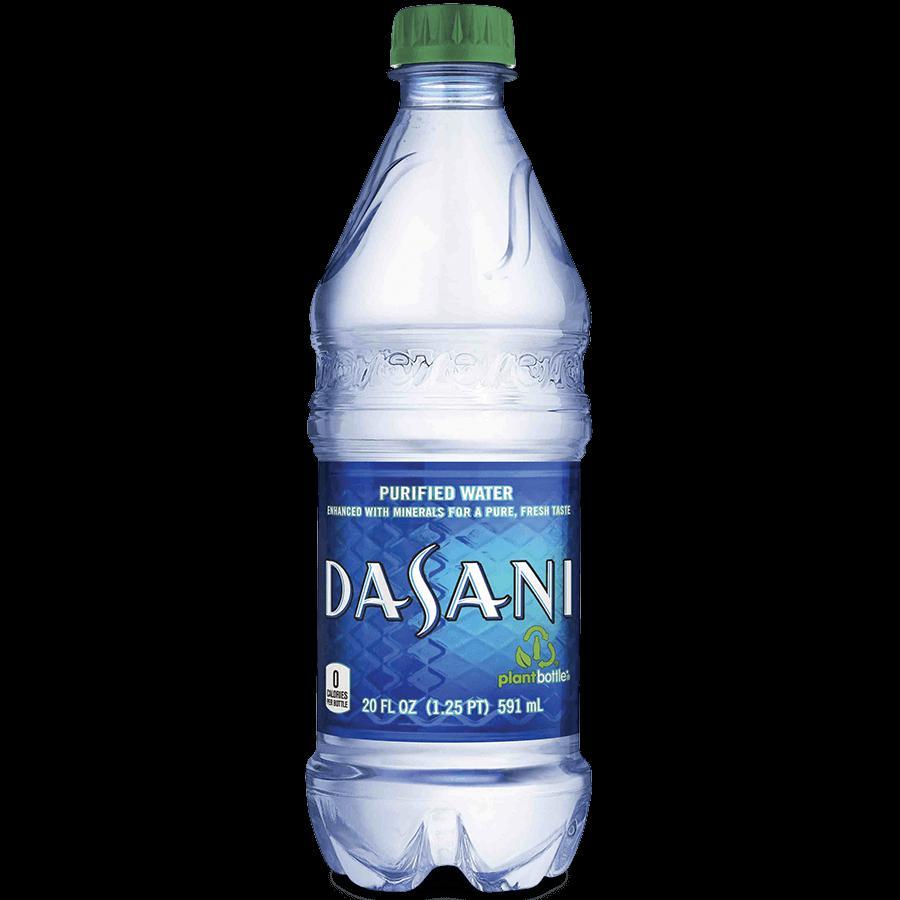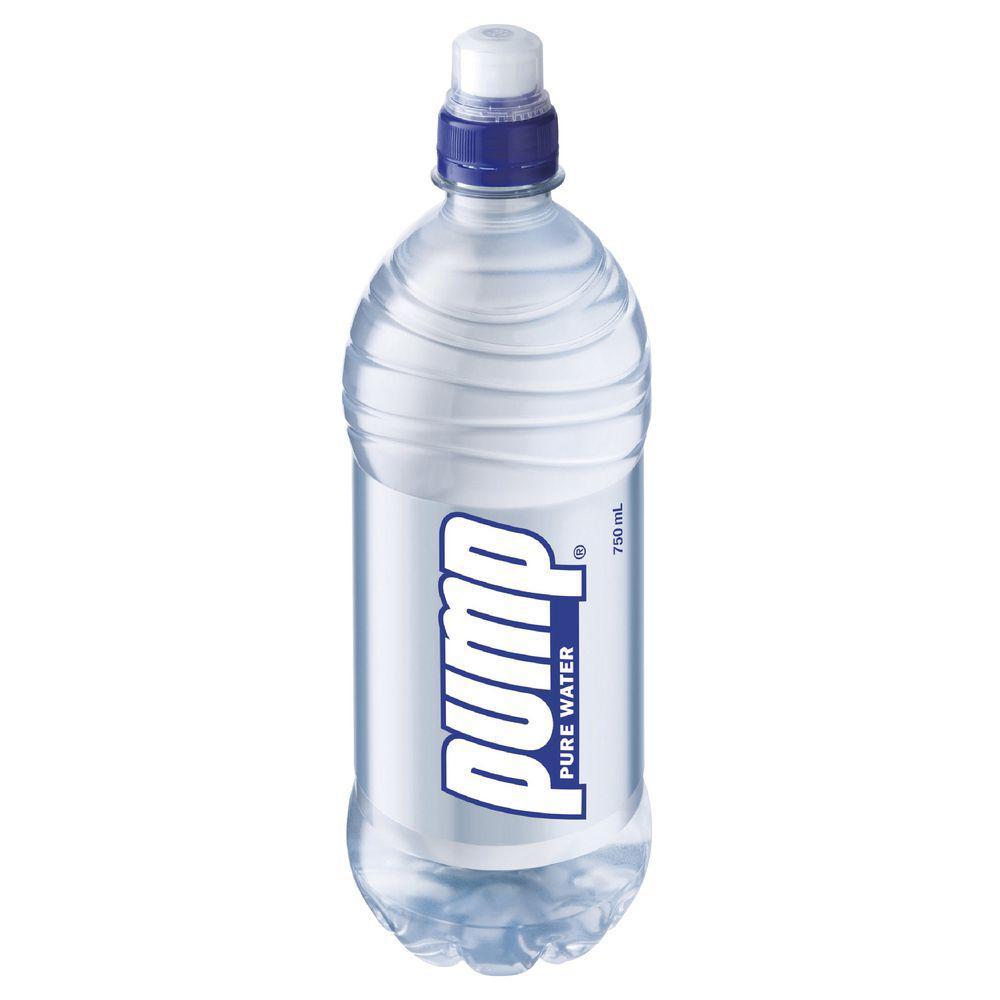The first image is the image on the left, the second image is the image on the right. Examine the images to the left and right. Is the description "At least one of the bottles doesn't have a lable." accurate? Answer yes or no. No. The first image is the image on the left, the second image is the image on the right. For the images displayed, is the sentence "Each image contains exactly one water bottle with a blue lid." factually correct? Answer yes or no. No. 